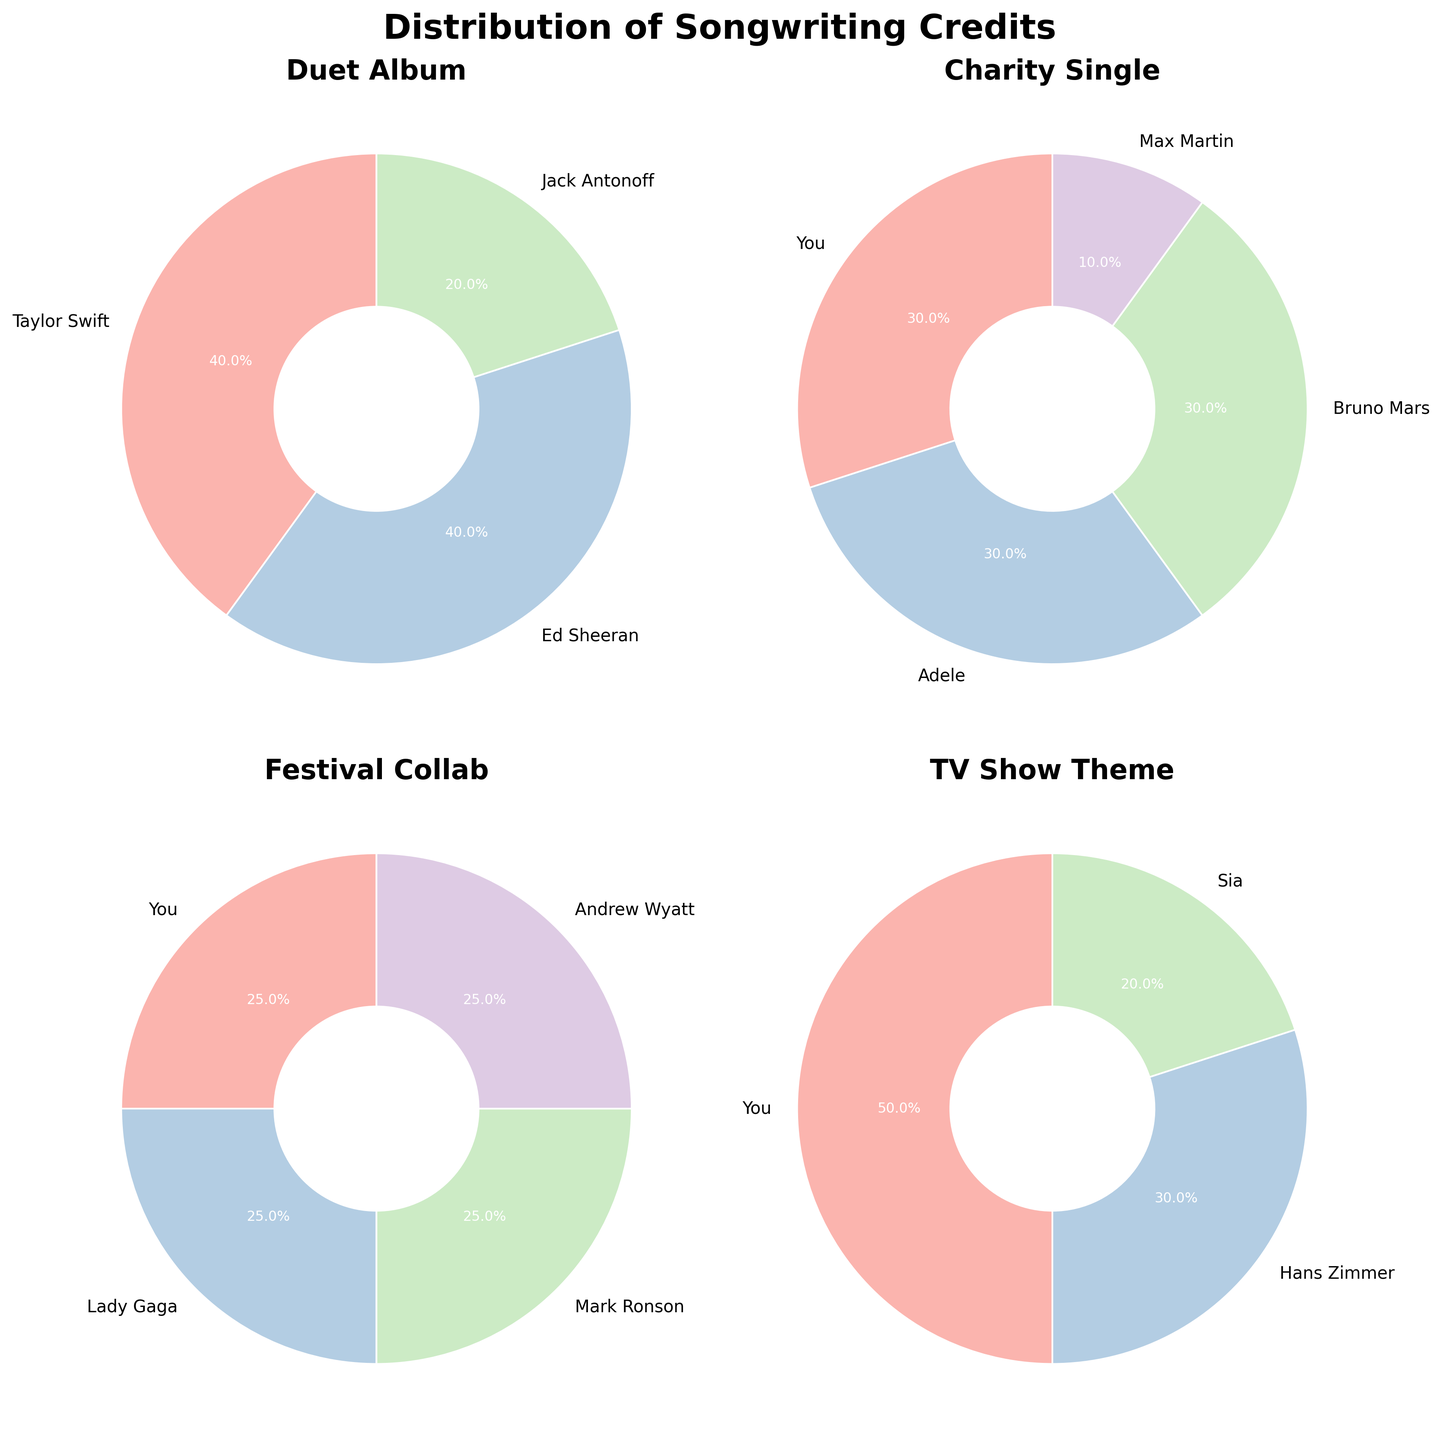How many songwriters contributed to the "TV Show Theme" project? The "TV Show Theme" pie chart shows segments labeled with the names of each songwriter. By counting these segments, we see there are three songwriters listed: You, Hans Zimmer, and Sia.
Answer: 3 Which project has the highest percentage of credits for a single songwriter? Looking at the pie charts, the "TV Show Theme" project has a segment labeled "You" with 50%, which is the highest individual percentage in all the charts.
Answer: TV Show Theme What is the total percentage of songwriting credits for "You" across all projects? Adding the percentages from all projects where "You" have credits: "Charity Single" (30%), "Festival Collab" (25%), "TV Show Theme" (50%). Summing them up gives 30 + 25 + 50 = 105%.
Answer: 105% How do the songwriting credits for "Festival Collab" compare among different songwriters? In the "Festival Collab" pie chart, all songwriters (You, Lady Gaga, Mark Ronson, Andrew Wyatt) have an equal percentage of 25%.
Answer: Equal Which songwriters have the smallest share of credits in any project, and in which projects are they? The smallest share of credits is 10%, which is held by Max Martin in the "Charity Single" project.
Answer: Max Martin, Charity Single What is the combined percentage of credits for Ed Sheeran across all projects? Ed Sheeran appears in the "Duet Album" project with a 40% share. Since he is only present in one project, his combined percentage is 40%.
Answer: 40% Which project demonstrates the most evenly distributed songwriting credits? The "Festival Collab" project has evenly distributed songwriting credits, with each songwriter having 25%.
Answer: Festival Collab In the "Duet Album" project, how does Jack Antonoff's credit compare to Taylor Swift's? In the "Duet Album" pie chart, Taylor Swift has 40%, while Jack Antonoff has 20%. Comparing these, Jack Antonoff has 20% less than Taylor Swift.
Answer: 20% less Which songwriters have contributed to more than one project? Based on the pie charts, only "You" have contributed to multiple projects: "Charity Single", "Festival Collab", and "TV Show Theme".
Answer: You 